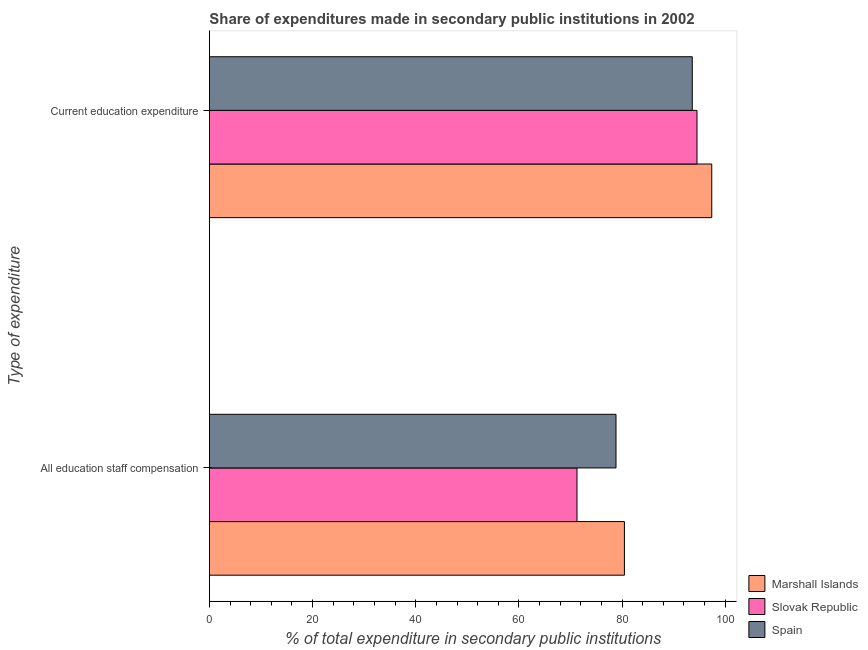How many different coloured bars are there?
Keep it short and to the point. 3. How many groups of bars are there?
Your answer should be very brief. 2. What is the label of the 1st group of bars from the top?
Ensure brevity in your answer.  Current education expenditure. What is the expenditure in staff compensation in Slovak Republic?
Your answer should be very brief. 71.26. Across all countries, what is the maximum expenditure in education?
Offer a very short reply. 97.38. Across all countries, what is the minimum expenditure in education?
Your answer should be compact. 93.6. In which country was the expenditure in staff compensation maximum?
Your answer should be compact. Marshall Islands. What is the total expenditure in education in the graph?
Your answer should be compact. 285.51. What is the difference between the expenditure in education in Slovak Republic and that in Marshall Islands?
Keep it short and to the point. -2.86. What is the difference between the expenditure in staff compensation in Slovak Republic and the expenditure in education in Marshall Islands?
Provide a short and direct response. -26.13. What is the average expenditure in education per country?
Keep it short and to the point. 95.17. What is the difference between the expenditure in staff compensation and expenditure in education in Slovak Republic?
Keep it short and to the point. -23.27. In how many countries, is the expenditure in staff compensation greater than 20 %?
Your answer should be very brief. 3. What is the ratio of the expenditure in staff compensation in Marshall Islands to that in Spain?
Offer a very short reply. 1.02. Is the expenditure in education in Slovak Republic less than that in Spain?
Ensure brevity in your answer.  No. What does the 1st bar from the bottom in All education staff compensation represents?
Ensure brevity in your answer.  Marshall Islands. How many countries are there in the graph?
Your answer should be compact. 3. Does the graph contain any zero values?
Offer a very short reply. No. Where does the legend appear in the graph?
Your answer should be very brief. Bottom right. How many legend labels are there?
Your answer should be very brief. 3. How are the legend labels stacked?
Offer a terse response. Vertical. What is the title of the graph?
Give a very brief answer. Share of expenditures made in secondary public institutions in 2002. Does "Gambia, The" appear as one of the legend labels in the graph?
Ensure brevity in your answer.  No. What is the label or title of the X-axis?
Make the answer very short. % of total expenditure in secondary public institutions. What is the label or title of the Y-axis?
Ensure brevity in your answer.  Type of expenditure. What is the % of total expenditure in secondary public institutions in Marshall Islands in All education staff compensation?
Offer a terse response. 80.45. What is the % of total expenditure in secondary public institutions in Slovak Republic in All education staff compensation?
Offer a very short reply. 71.26. What is the % of total expenditure in secondary public institutions of Spain in All education staff compensation?
Make the answer very short. 78.82. What is the % of total expenditure in secondary public institutions of Marshall Islands in Current education expenditure?
Make the answer very short. 97.38. What is the % of total expenditure in secondary public institutions of Slovak Republic in Current education expenditure?
Your answer should be compact. 94.52. What is the % of total expenditure in secondary public institutions in Spain in Current education expenditure?
Provide a succinct answer. 93.6. Across all Type of expenditure, what is the maximum % of total expenditure in secondary public institutions in Marshall Islands?
Ensure brevity in your answer.  97.38. Across all Type of expenditure, what is the maximum % of total expenditure in secondary public institutions of Slovak Republic?
Offer a very short reply. 94.52. Across all Type of expenditure, what is the maximum % of total expenditure in secondary public institutions in Spain?
Your response must be concise. 93.6. Across all Type of expenditure, what is the minimum % of total expenditure in secondary public institutions in Marshall Islands?
Keep it short and to the point. 80.45. Across all Type of expenditure, what is the minimum % of total expenditure in secondary public institutions in Slovak Republic?
Keep it short and to the point. 71.26. Across all Type of expenditure, what is the minimum % of total expenditure in secondary public institutions in Spain?
Keep it short and to the point. 78.82. What is the total % of total expenditure in secondary public institutions in Marshall Islands in the graph?
Your response must be concise. 177.83. What is the total % of total expenditure in secondary public institutions in Slovak Republic in the graph?
Provide a succinct answer. 165.78. What is the total % of total expenditure in secondary public institutions of Spain in the graph?
Provide a short and direct response. 172.42. What is the difference between the % of total expenditure in secondary public institutions of Marshall Islands in All education staff compensation and that in Current education expenditure?
Offer a terse response. -16.93. What is the difference between the % of total expenditure in secondary public institutions in Slovak Republic in All education staff compensation and that in Current education expenditure?
Provide a succinct answer. -23.27. What is the difference between the % of total expenditure in secondary public institutions of Spain in All education staff compensation and that in Current education expenditure?
Provide a succinct answer. -14.79. What is the difference between the % of total expenditure in secondary public institutions of Marshall Islands in All education staff compensation and the % of total expenditure in secondary public institutions of Slovak Republic in Current education expenditure?
Offer a terse response. -14.07. What is the difference between the % of total expenditure in secondary public institutions of Marshall Islands in All education staff compensation and the % of total expenditure in secondary public institutions of Spain in Current education expenditure?
Offer a terse response. -13.15. What is the difference between the % of total expenditure in secondary public institutions in Slovak Republic in All education staff compensation and the % of total expenditure in secondary public institutions in Spain in Current education expenditure?
Provide a succinct answer. -22.35. What is the average % of total expenditure in secondary public institutions of Marshall Islands per Type of expenditure?
Provide a short and direct response. 88.92. What is the average % of total expenditure in secondary public institutions in Slovak Republic per Type of expenditure?
Your answer should be compact. 82.89. What is the average % of total expenditure in secondary public institutions of Spain per Type of expenditure?
Give a very brief answer. 86.21. What is the difference between the % of total expenditure in secondary public institutions in Marshall Islands and % of total expenditure in secondary public institutions in Slovak Republic in All education staff compensation?
Offer a terse response. 9.2. What is the difference between the % of total expenditure in secondary public institutions in Marshall Islands and % of total expenditure in secondary public institutions in Spain in All education staff compensation?
Offer a very short reply. 1.63. What is the difference between the % of total expenditure in secondary public institutions of Slovak Republic and % of total expenditure in secondary public institutions of Spain in All education staff compensation?
Provide a short and direct response. -7.56. What is the difference between the % of total expenditure in secondary public institutions of Marshall Islands and % of total expenditure in secondary public institutions of Slovak Republic in Current education expenditure?
Make the answer very short. 2.86. What is the difference between the % of total expenditure in secondary public institutions of Marshall Islands and % of total expenditure in secondary public institutions of Spain in Current education expenditure?
Provide a succinct answer. 3.78. What is the difference between the % of total expenditure in secondary public institutions of Slovak Republic and % of total expenditure in secondary public institutions of Spain in Current education expenditure?
Give a very brief answer. 0.92. What is the ratio of the % of total expenditure in secondary public institutions in Marshall Islands in All education staff compensation to that in Current education expenditure?
Your answer should be compact. 0.83. What is the ratio of the % of total expenditure in secondary public institutions in Slovak Republic in All education staff compensation to that in Current education expenditure?
Provide a short and direct response. 0.75. What is the ratio of the % of total expenditure in secondary public institutions in Spain in All education staff compensation to that in Current education expenditure?
Provide a short and direct response. 0.84. What is the difference between the highest and the second highest % of total expenditure in secondary public institutions in Marshall Islands?
Your answer should be very brief. 16.93. What is the difference between the highest and the second highest % of total expenditure in secondary public institutions in Slovak Republic?
Your answer should be very brief. 23.27. What is the difference between the highest and the second highest % of total expenditure in secondary public institutions of Spain?
Offer a terse response. 14.79. What is the difference between the highest and the lowest % of total expenditure in secondary public institutions of Marshall Islands?
Offer a terse response. 16.93. What is the difference between the highest and the lowest % of total expenditure in secondary public institutions in Slovak Republic?
Keep it short and to the point. 23.27. What is the difference between the highest and the lowest % of total expenditure in secondary public institutions in Spain?
Ensure brevity in your answer.  14.79. 